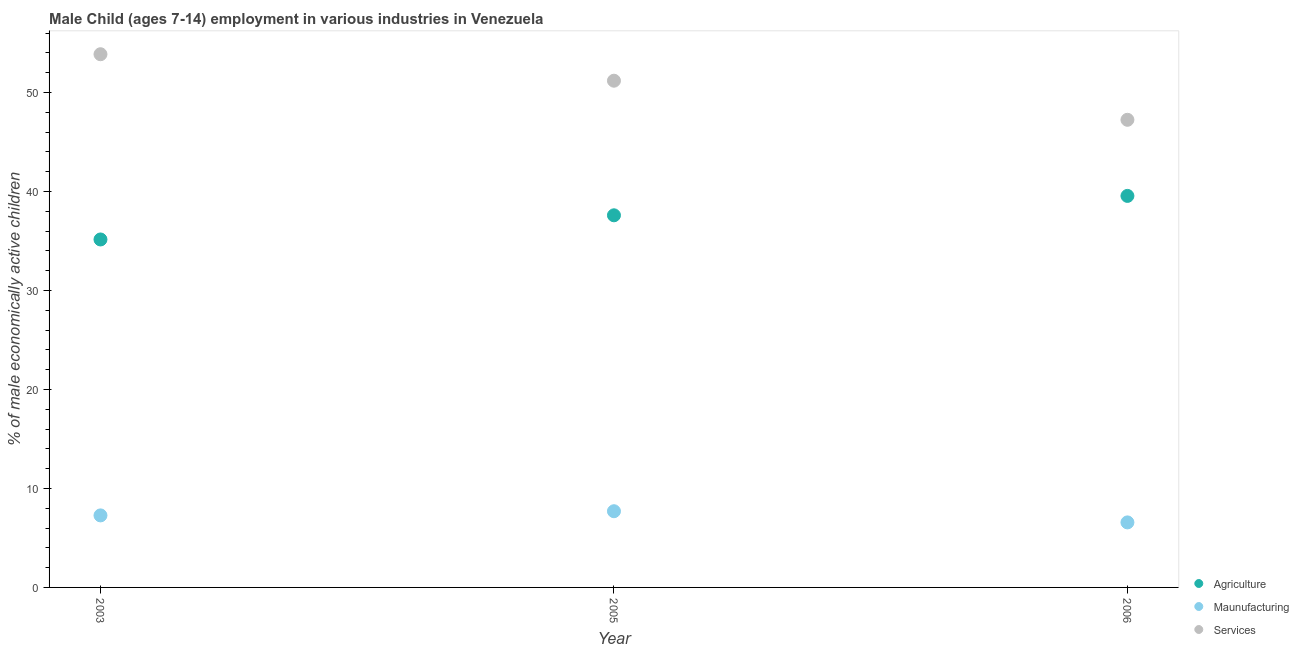Is the number of dotlines equal to the number of legend labels?
Your response must be concise. Yes. What is the percentage of economically active children in manufacturing in 2006?
Offer a terse response. 6.57. Across all years, what is the maximum percentage of economically active children in services?
Give a very brief answer. 53.87. Across all years, what is the minimum percentage of economically active children in services?
Keep it short and to the point. 47.25. What is the total percentage of economically active children in agriculture in the graph?
Provide a short and direct response. 112.32. What is the difference between the percentage of economically active children in agriculture in 2003 and that in 2006?
Provide a short and direct response. -4.4. What is the difference between the percentage of economically active children in agriculture in 2003 and the percentage of economically active children in manufacturing in 2005?
Your answer should be very brief. 27.46. What is the average percentage of economically active children in agriculture per year?
Your answer should be compact. 37.44. In the year 2006, what is the difference between the percentage of economically active children in agriculture and percentage of economically active children in manufacturing?
Keep it short and to the point. 32.99. What is the ratio of the percentage of economically active children in agriculture in 2003 to that in 2005?
Give a very brief answer. 0.94. Is the percentage of economically active children in manufacturing in 2003 less than that in 2006?
Keep it short and to the point. No. What is the difference between the highest and the second highest percentage of economically active children in services?
Provide a succinct answer. 2.67. What is the difference between the highest and the lowest percentage of economically active children in manufacturing?
Provide a short and direct response. 1.13. In how many years, is the percentage of economically active children in agriculture greater than the average percentage of economically active children in agriculture taken over all years?
Offer a very short reply. 2. Is it the case that in every year, the sum of the percentage of economically active children in agriculture and percentage of economically active children in manufacturing is greater than the percentage of economically active children in services?
Keep it short and to the point. No. Does the percentage of economically active children in manufacturing monotonically increase over the years?
Keep it short and to the point. No. Is the percentage of economically active children in manufacturing strictly greater than the percentage of economically active children in services over the years?
Your response must be concise. No. How many years are there in the graph?
Keep it short and to the point. 3. Does the graph contain grids?
Your answer should be compact. No. How are the legend labels stacked?
Offer a very short reply. Vertical. What is the title of the graph?
Your response must be concise. Male Child (ages 7-14) employment in various industries in Venezuela. Does "Private sector" appear as one of the legend labels in the graph?
Your answer should be very brief. No. What is the label or title of the X-axis?
Your answer should be compact. Year. What is the label or title of the Y-axis?
Make the answer very short. % of male economically active children. What is the % of male economically active children in Agriculture in 2003?
Give a very brief answer. 35.16. What is the % of male economically active children in Maunufacturing in 2003?
Keep it short and to the point. 7.28. What is the % of male economically active children of Services in 2003?
Your answer should be very brief. 53.87. What is the % of male economically active children in Agriculture in 2005?
Offer a terse response. 37.6. What is the % of male economically active children of Services in 2005?
Your answer should be very brief. 51.2. What is the % of male economically active children of Agriculture in 2006?
Make the answer very short. 39.56. What is the % of male economically active children in Maunufacturing in 2006?
Provide a succinct answer. 6.57. What is the % of male economically active children in Services in 2006?
Keep it short and to the point. 47.25. Across all years, what is the maximum % of male economically active children in Agriculture?
Provide a short and direct response. 39.56. Across all years, what is the maximum % of male economically active children of Maunufacturing?
Your response must be concise. 7.7. Across all years, what is the maximum % of male economically active children of Services?
Your response must be concise. 53.87. Across all years, what is the minimum % of male economically active children in Agriculture?
Offer a terse response. 35.16. Across all years, what is the minimum % of male economically active children in Maunufacturing?
Make the answer very short. 6.57. Across all years, what is the minimum % of male economically active children in Services?
Ensure brevity in your answer.  47.25. What is the total % of male economically active children in Agriculture in the graph?
Make the answer very short. 112.32. What is the total % of male economically active children in Maunufacturing in the graph?
Give a very brief answer. 21.55. What is the total % of male economically active children of Services in the graph?
Your response must be concise. 152.32. What is the difference between the % of male economically active children of Agriculture in 2003 and that in 2005?
Make the answer very short. -2.44. What is the difference between the % of male economically active children in Maunufacturing in 2003 and that in 2005?
Your answer should be very brief. -0.42. What is the difference between the % of male economically active children in Services in 2003 and that in 2005?
Your answer should be very brief. 2.67. What is the difference between the % of male economically active children in Agriculture in 2003 and that in 2006?
Your response must be concise. -4.4. What is the difference between the % of male economically active children of Maunufacturing in 2003 and that in 2006?
Keep it short and to the point. 0.71. What is the difference between the % of male economically active children of Services in 2003 and that in 2006?
Provide a succinct answer. 6.62. What is the difference between the % of male economically active children of Agriculture in 2005 and that in 2006?
Provide a short and direct response. -1.96. What is the difference between the % of male economically active children in Maunufacturing in 2005 and that in 2006?
Your answer should be compact. 1.13. What is the difference between the % of male economically active children of Services in 2005 and that in 2006?
Keep it short and to the point. 3.95. What is the difference between the % of male economically active children in Agriculture in 2003 and the % of male economically active children in Maunufacturing in 2005?
Give a very brief answer. 27.46. What is the difference between the % of male economically active children of Agriculture in 2003 and the % of male economically active children of Services in 2005?
Your response must be concise. -16.04. What is the difference between the % of male economically active children of Maunufacturing in 2003 and the % of male economically active children of Services in 2005?
Your answer should be compact. -43.92. What is the difference between the % of male economically active children in Agriculture in 2003 and the % of male economically active children in Maunufacturing in 2006?
Provide a short and direct response. 28.59. What is the difference between the % of male economically active children in Agriculture in 2003 and the % of male economically active children in Services in 2006?
Provide a short and direct response. -12.09. What is the difference between the % of male economically active children in Maunufacturing in 2003 and the % of male economically active children in Services in 2006?
Make the answer very short. -39.97. What is the difference between the % of male economically active children of Agriculture in 2005 and the % of male economically active children of Maunufacturing in 2006?
Make the answer very short. 31.03. What is the difference between the % of male economically active children of Agriculture in 2005 and the % of male economically active children of Services in 2006?
Offer a very short reply. -9.65. What is the difference between the % of male economically active children in Maunufacturing in 2005 and the % of male economically active children in Services in 2006?
Make the answer very short. -39.55. What is the average % of male economically active children in Agriculture per year?
Ensure brevity in your answer.  37.44. What is the average % of male economically active children of Maunufacturing per year?
Provide a short and direct response. 7.18. What is the average % of male economically active children in Services per year?
Give a very brief answer. 50.77. In the year 2003, what is the difference between the % of male economically active children of Agriculture and % of male economically active children of Maunufacturing?
Make the answer very short. 27.88. In the year 2003, what is the difference between the % of male economically active children in Agriculture and % of male economically active children in Services?
Provide a short and direct response. -18.72. In the year 2003, what is the difference between the % of male economically active children of Maunufacturing and % of male economically active children of Services?
Make the answer very short. -46.6. In the year 2005, what is the difference between the % of male economically active children in Agriculture and % of male economically active children in Maunufacturing?
Make the answer very short. 29.9. In the year 2005, what is the difference between the % of male economically active children of Maunufacturing and % of male economically active children of Services?
Your response must be concise. -43.5. In the year 2006, what is the difference between the % of male economically active children in Agriculture and % of male economically active children in Maunufacturing?
Your answer should be compact. 32.99. In the year 2006, what is the difference between the % of male economically active children of Agriculture and % of male economically active children of Services?
Offer a very short reply. -7.69. In the year 2006, what is the difference between the % of male economically active children in Maunufacturing and % of male economically active children in Services?
Give a very brief answer. -40.68. What is the ratio of the % of male economically active children of Agriculture in 2003 to that in 2005?
Offer a very short reply. 0.94. What is the ratio of the % of male economically active children of Maunufacturing in 2003 to that in 2005?
Your answer should be compact. 0.95. What is the ratio of the % of male economically active children of Services in 2003 to that in 2005?
Keep it short and to the point. 1.05. What is the ratio of the % of male economically active children of Agriculture in 2003 to that in 2006?
Keep it short and to the point. 0.89. What is the ratio of the % of male economically active children of Maunufacturing in 2003 to that in 2006?
Keep it short and to the point. 1.11. What is the ratio of the % of male economically active children of Services in 2003 to that in 2006?
Provide a succinct answer. 1.14. What is the ratio of the % of male economically active children of Agriculture in 2005 to that in 2006?
Your response must be concise. 0.95. What is the ratio of the % of male economically active children in Maunufacturing in 2005 to that in 2006?
Offer a very short reply. 1.17. What is the ratio of the % of male economically active children of Services in 2005 to that in 2006?
Offer a very short reply. 1.08. What is the difference between the highest and the second highest % of male economically active children of Agriculture?
Keep it short and to the point. 1.96. What is the difference between the highest and the second highest % of male economically active children in Maunufacturing?
Your response must be concise. 0.42. What is the difference between the highest and the second highest % of male economically active children in Services?
Your answer should be very brief. 2.67. What is the difference between the highest and the lowest % of male economically active children of Agriculture?
Your answer should be very brief. 4.4. What is the difference between the highest and the lowest % of male economically active children of Maunufacturing?
Your response must be concise. 1.13. What is the difference between the highest and the lowest % of male economically active children in Services?
Keep it short and to the point. 6.62. 